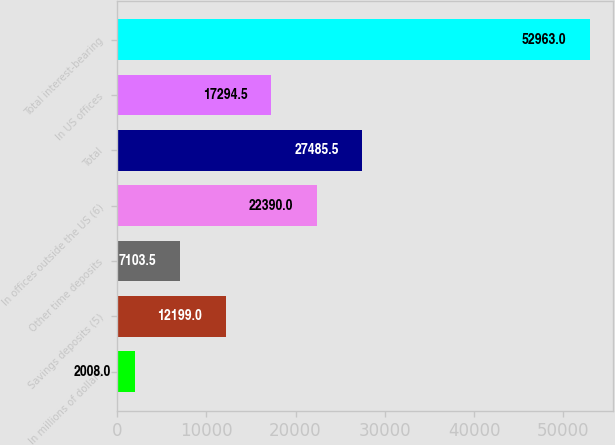<chart> <loc_0><loc_0><loc_500><loc_500><bar_chart><fcel>In millions of dollars<fcel>Savings deposits (5)<fcel>Other time deposits<fcel>In offices outside the US (6)<fcel>Total<fcel>In US offices<fcel>Total interest-bearing<nl><fcel>2008<fcel>12199<fcel>7103.5<fcel>22390<fcel>27485.5<fcel>17294.5<fcel>52963<nl></chart> 